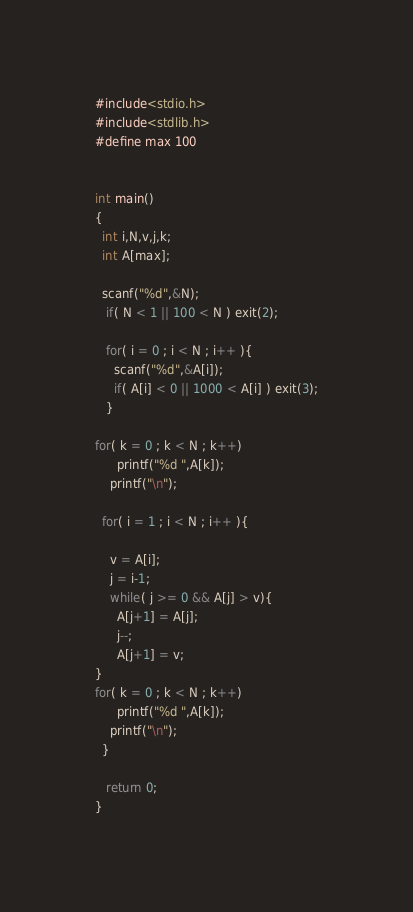<code> <loc_0><loc_0><loc_500><loc_500><_C_>#include<stdio.h>
#include<stdlib.h>
#define max 100


int main()
{
  int i,N,v,j,k;
  int A[max];

  scanf("%d",&N);
   if( N < 1 || 100 < N ) exit(2);

   for( i = 0 ; i < N ; i++ ){
     scanf("%d",&A[i]);
     if( A[i] < 0 || 1000 < A[i] ) exit(3);
   }

for( k = 0 ; k < N ; k++)
      printf("%d ",A[k]);
    printf("\n");

  for( i = 1 ; i < N ; i++ ){

    v = A[i];
    j = i-1;
    while( j >= 0 && A[j] > v){
      A[j+1] = A[j];
      j--;
      A[j+1] = v;
}   
for( k = 0 ; k < N ; k++)
      printf("%d ",A[k]);
    printf("\n");
  }

   return 0;
}</code> 